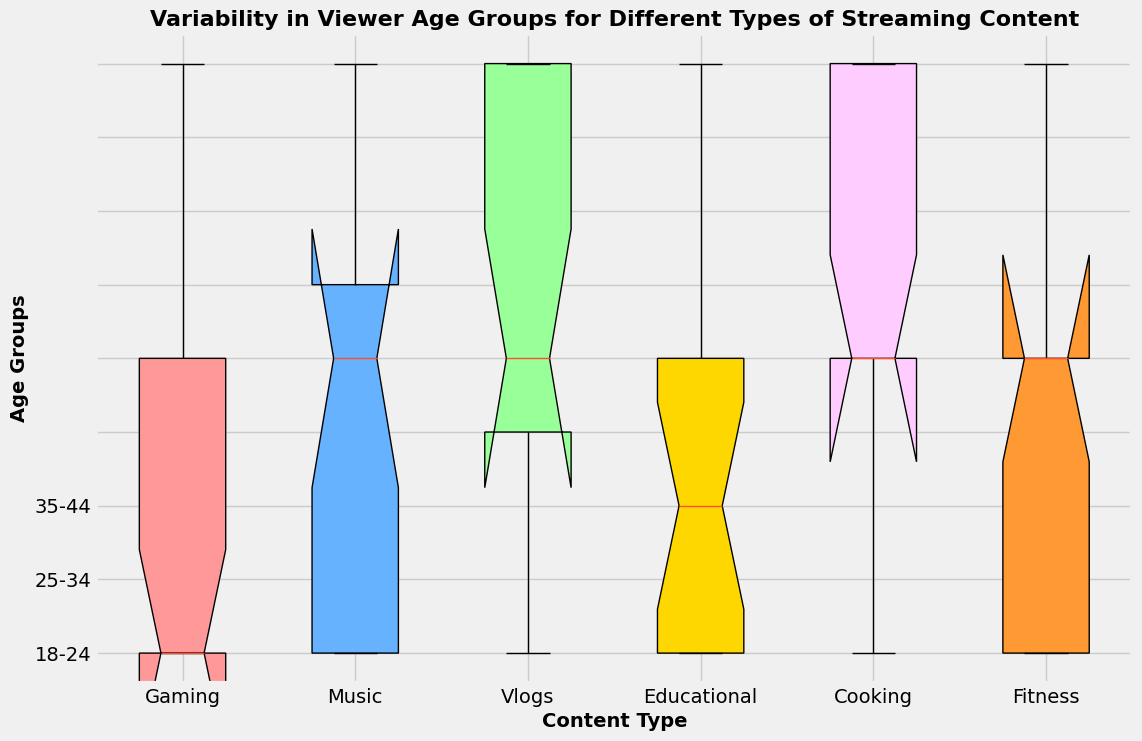What is the median age group for educational content? The median is the middle value in the dataset. For educational content, look at the box plot corresponding to this category and identify the middle line within the box. The middle line within the educational content box plot is in the range '18-24'.
Answer: 18-24 Which content type has the widest variability in age groups? The content type with the widest variability will have the largest range (distance from the bottom of the box to the top and whiskers). Look at all the box plots and identify the one with the largest spread. Vlogs have the widest spread, ranging from '18-24' to '35-44'.
Answer: Vlogs Which age group is the most common for gaming content? To find the most common (or mode) age group, observe the height and density of the boxed area. The box plot for gaming content is densest around '18-24'.
Answer: 18-24 Do fitness and cooking content have viewers in the '18-24' age group? Check the box plots for both fitness and cooking and see the extent of the segments to confirm if '18-24' is included. Both box plots show the '18-24' range.
Answer: Yes Are there any content types that do not show any viewers in the '35-44' age group? Identify the content types with box plots that do not extend to the '35-44' age group. Gaming content plots do not extend to the '35-44' range, indicating no viewers in this group for this content type.
Answer: Gaming Is the median age group for music content older than that for gaming content? Compare the middle line of the box plots for music and gaming. The median for music is higher ('25-34') compared to gaming ('18-24').
Answer: Yes Which content type has the smallest interquartile range (IQR) of viewer ages? The interquartile range (IQR) is the distance between the top and bottom of the box. Observe and compare the size of the boxes. Music content has the smallest IQR.
Answer: Music What is the modal age group for fitness and vlog content? The modal age group is the range with the highest occurrence. For fitness and vlogs, check the box with the highest density. Both fitness and vlog content mode is '18-24'.
Answer: 18-24 In which content type do viewers' ages range from '18-24' to '35-44'? Check the range of each box plot. Vlog, cooking, educational, and fitness content types encompass age ranges from '18-24' to '35-44'.
Answer: Vlog, Cooking, Educational, Fitness 